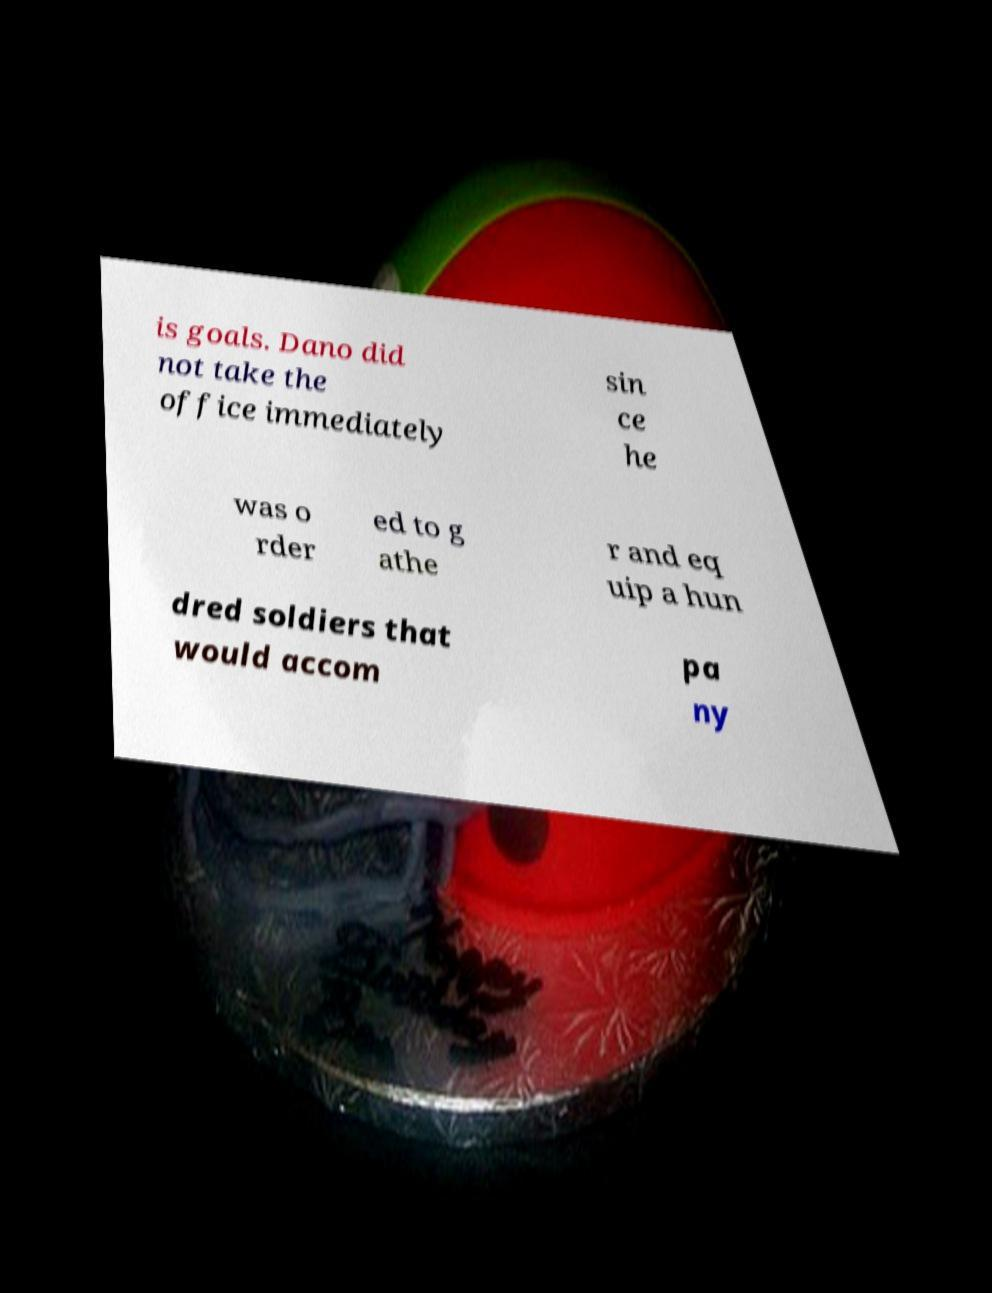Can you read and provide the text displayed in the image?This photo seems to have some interesting text. Can you extract and type it out for me? is goals. Dano did not take the office immediately sin ce he was o rder ed to g athe r and eq uip a hun dred soldiers that would accom pa ny 